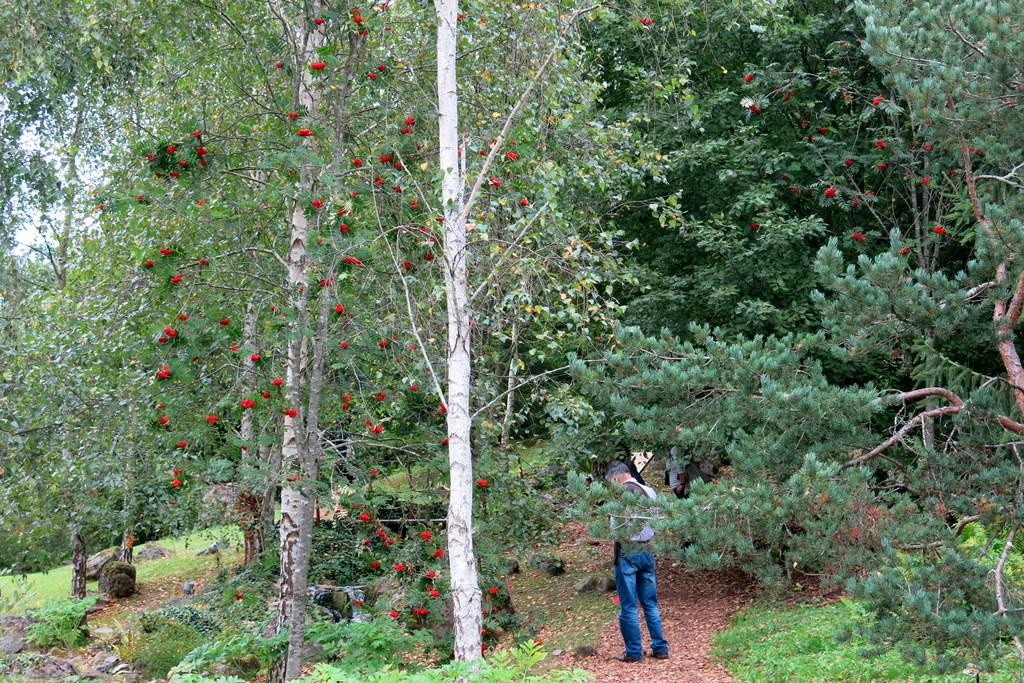What is the main subject of the image? There is a person standing in the image. What can be seen in the background of the image? There are trees surrounding the person in the image. What type of scissors is the person using to cut the wool in the image? There is no scissors or wool present in the image; the person is simply standing among trees. 